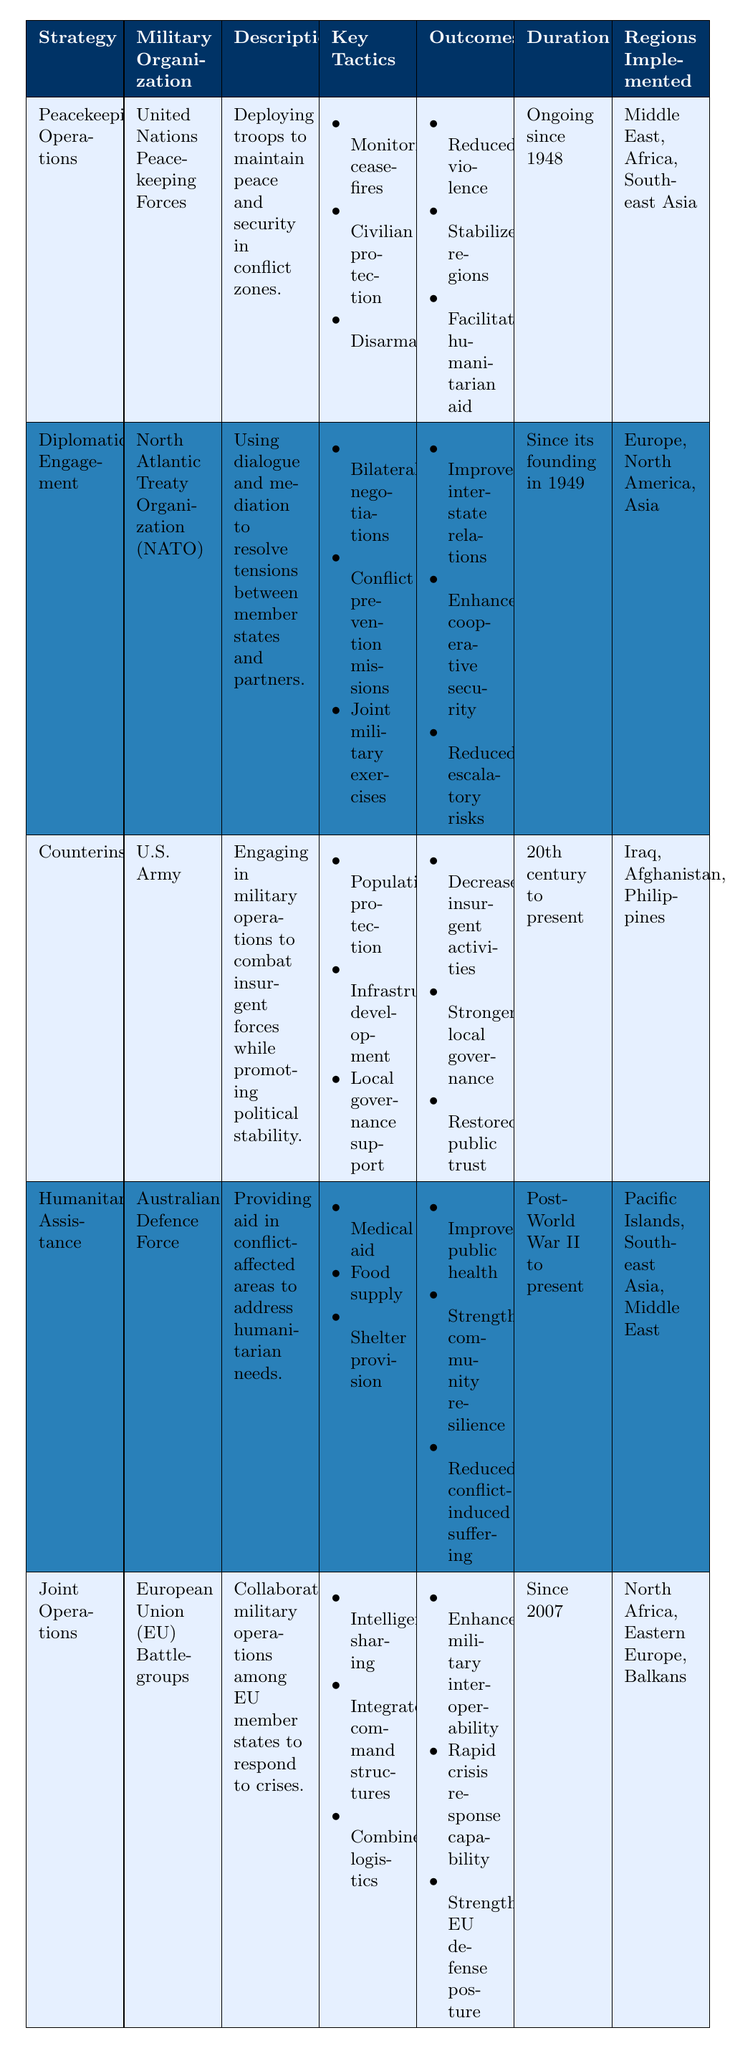What is the strategy of the United Nations Peacekeeping Forces? According to the table, the strategy for the United Nations Peacekeeping Forces is "Peacekeeping Operations."
Answer: Peacekeeping Operations What key tactics are used in Counterinsurgency? The key tactics listed for Counterinsurgency by the U.S. Army include population protection, infrastructure development, and local governance support.
Answer: Population protection, infrastructure development, local governance support Which military organization has been involved in Joint Operations since 2007? The European Union (EU) Battlegroups are the military organization involved in Joint Operations, and the table specifies that this has been ongoing since 2007.
Answer: European Union (EU) Battlegroups What outcome is specifically linked to the strategy of Humanitarian Assistance? The outcomes linked to Humanitarian Assistance by the Australian Defence Force include improved public health, strengthened community resilience, and reduced conflict-induced suffering.
Answer: Improved public health, strengthened community resilience, reduced conflict-induced suffering How many strategies are implemented in the Middle East according to the table? The table shows that both the Peacekeeping Operations and Humanitarian Assistance strategies are implemented in the Middle East, totaling two strategies.
Answer: 2 Is the strategy of Diplomatic Engagement focused on military operations? The table indicates that Diplomatic Engagement involves using dialogue and mediation, not military operations; therefore, the statement is false.
Answer: No What is the duration of Peacekeeping Operations? The table states that Peacekeeping Operations have been ongoing since 1948.
Answer: Ongoing since 1948 Which region is associated with the Counterinsurgency strategy? The regions implemented for Counterinsurgency by the U.S. Army are Iraq, Afghanistan, and the Philippines, as mentioned in the table.
Answer: Iraq, Afghanistan, Philippines What are the outcomes of the Joint Operations strategy? The outcomes listed for the Joint Operations strategy include enhanced military interoperability, rapid crisis response capability, and strengthened EU defense posture.
Answer: Enhanced military interoperability, rapid crisis response capability, strengthened EU defense posture Which strategy has the longest duration of implementation based on the table? The table shows that Peacekeeping Operations have been ongoing since 1948, which is longer than any other strategy listed.
Answer: Peacekeeping Operations 